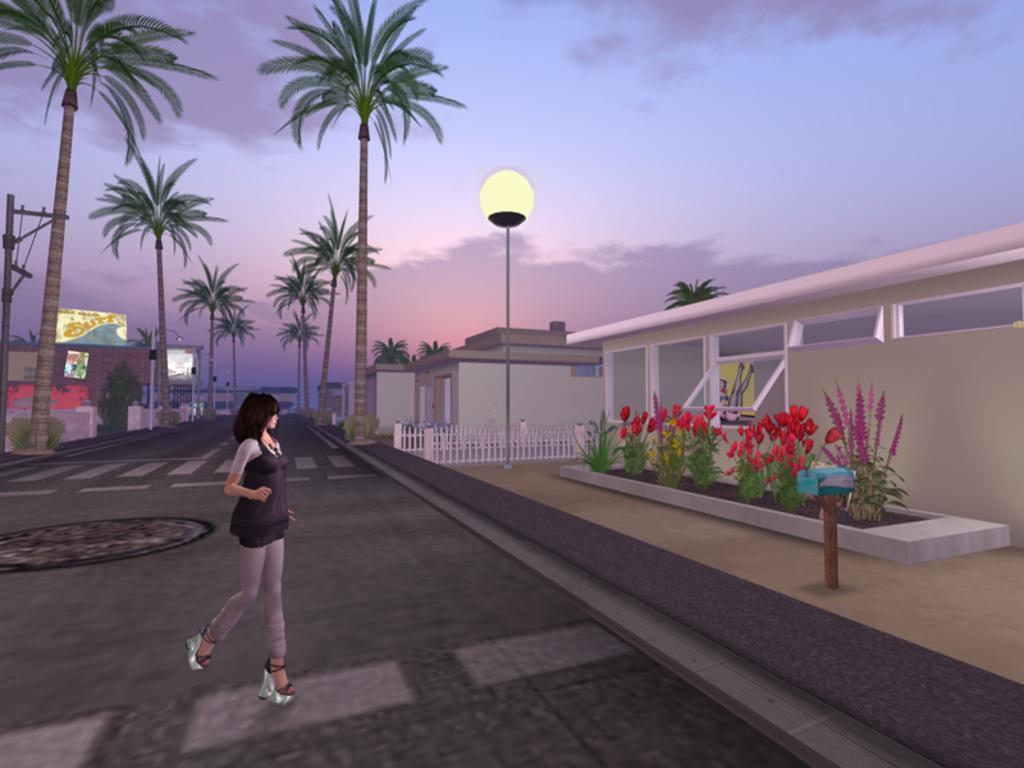In one or two sentences, can you explain what this image depicts? In the image we can see there is an animation picture in which a woman is standing on the road. Behind there are trees and there are buildings. There are flowers and plants on the ground near the building. 